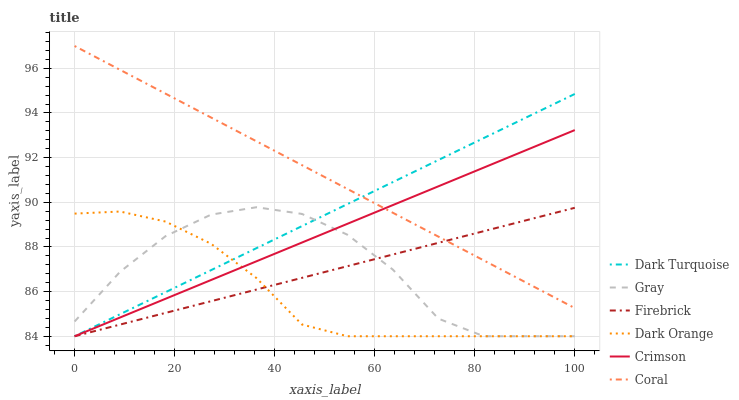Does Dark Orange have the minimum area under the curve?
Answer yes or no. Yes. Does Coral have the maximum area under the curve?
Answer yes or no. Yes. Does Gray have the minimum area under the curve?
Answer yes or no. No. Does Gray have the maximum area under the curve?
Answer yes or no. No. Is Firebrick the smoothest?
Answer yes or no. Yes. Is Gray the roughest?
Answer yes or no. Yes. Is Dark Turquoise the smoothest?
Answer yes or no. No. Is Dark Turquoise the roughest?
Answer yes or no. No. Does Dark Orange have the lowest value?
Answer yes or no. Yes. Does Coral have the lowest value?
Answer yes or no. No. Does Coral have the highest value?
Answer yes or no. Yes. Does Gray have the highest value?
Answer yes or no. No. Is Dark Orange less than Coral?
Answer yes or no. Yes. Is Coral greater than Gray?
Answer yes or no. Yes. Does Dark Turquoise intersect Coral?
Answer yes or no. Yes. Is Dark Turquoise less than Coral?
Answer yes or no. No. Is Dark Turquoise greater than Coral?
Answer yes or no. No. Does Dark Orange intersect Coral?
Answer yes or no. No. 